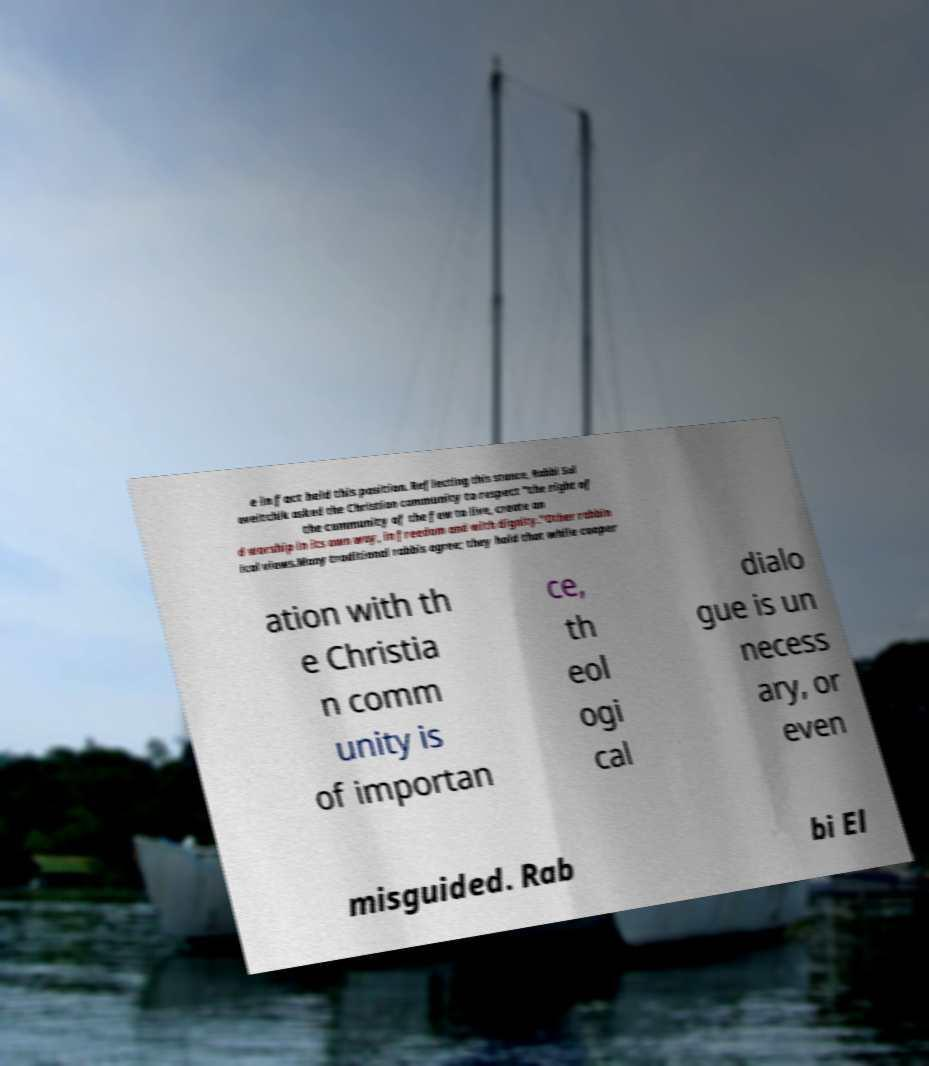Can you accurately transcribe the text from the provided image for me? e in fact held this position. Reflecting this stance, Rabbi Sol oveitchik asked the Christian community to respect "the right of the community of the few to live, create an d worship in its own way, in freedom and with dignity."Other rabbin ical views.Many traditional rabbis agree; they hold that while cooper ation with th e Christia n comm unity is of importan ce, th eol ogi cal dialo gue is un necess ary, or even misguided. Rab bi El 